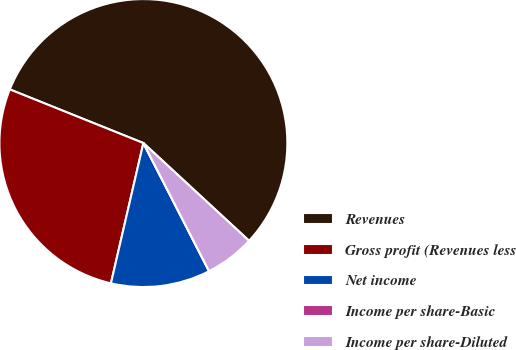Convert chart to OTSL. <chart><loc_0><loc_0><loc_500><loc_500><pie_chart><fcel>Revenues<fcel>Gross profit (Revenues less<fcel>Net income<fcel>Income per share-Basic<fcel>Income per share-Diluted<nl><fcel>55.8%<fcel>27.46%<fcel>11.16%<fcel>0.0%<fcel>5.58%<nl></chart> 